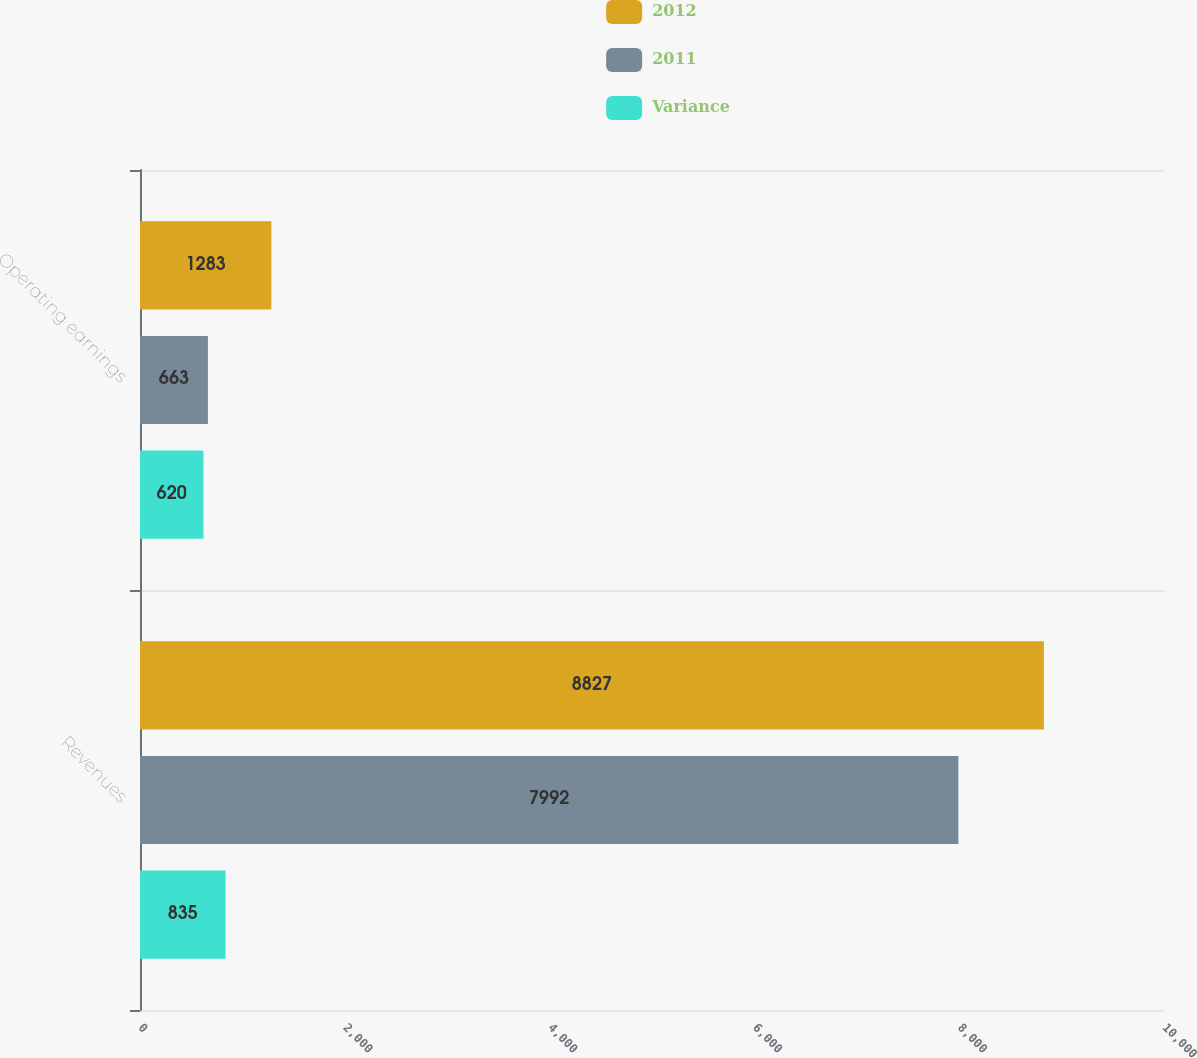Convert chart to OTSL. <chart><loc_0><loc_0><loc_500><loc_500><stacked_bar_chart><ecel><fcel>Revenues<fcel>Operating earnings<nl><fcel>2012<fcel>8827<fcel>1283<nl><fcel>2011<fcel>7992<fcel>663<nl><fcel>Variance<fcel>835<fcel>620<nl></chart> 